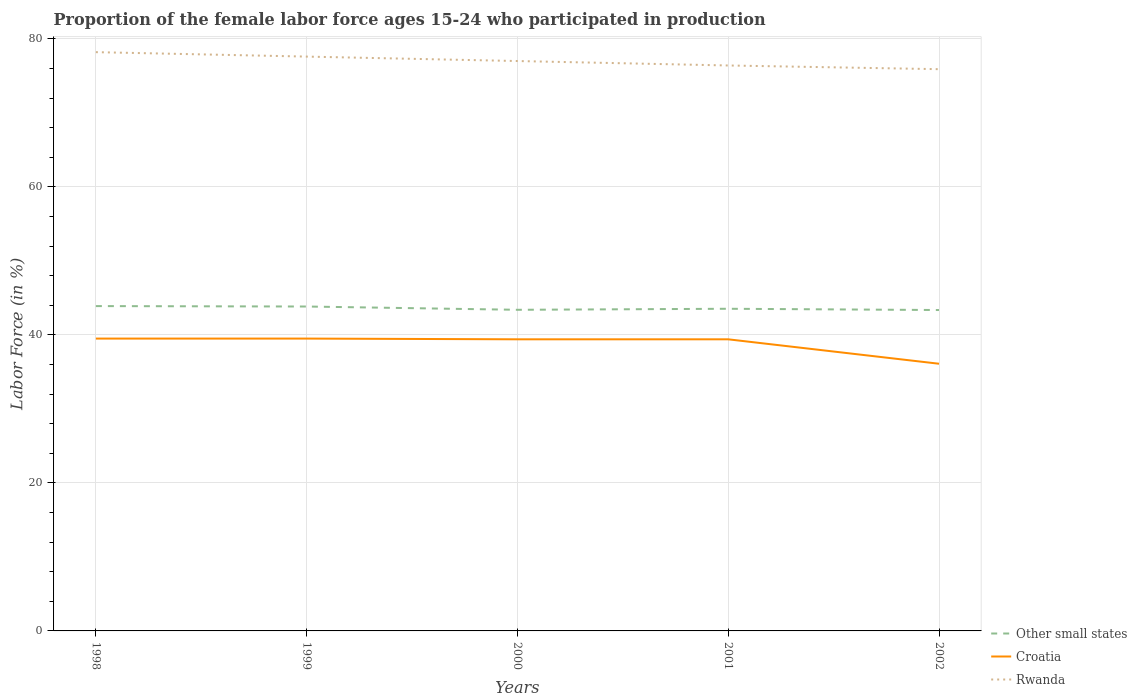Does the line corresponding to Other small states intersect with the line corresponding to Rwanda?
Your answer should be compact. No. Across all years, what is the maximum proportion of the female labor force who participated in production in Other small states?
Provide a succinct answer. 43.36. In which year was the proportion of the female labor force who participated in production in Rwanda maximum?
Offer a very short reply. 2002. What is the total proportion of the female labor force who participated in production in Rwanda in the graph?
Make the answer very short. 0.6. What is the difference between the highest and the second highest proportion of the female labor force who participated in production in Rwanda?
Offer a terse response. 2.3. What is the difference between the highest and the lowest proportion of the female labor force who participated in production in Croatia?
Give a very brief answer. 4. Is the proportion of the female labor force who participated in production in Croatia strictly greater than the proportion of the female labor force who participated in production in Rwanda over the years?
Make the answer very short. Yes. How many lines are there?
Provide a succinct answer. 3. How many years are there in the graph?
Your response must be concise. 5. Are the values on the major ticks of Y-axis written in scientific E-notation?
Give a very brief answer. No. Does the graph contain grids?
Offer a terse response. Yes. Where does the legend appear in the graph?
Your answer should be compact. Bottom right. How many legend labels are there?
Ensure brevity in your answer.  3. What is the title of the graph?
Offer a terse response. Proportion of the female labor force ages 15-24 who participated in production. What is the label or title of the X-axis?
Your answer should be very brief. Years. What is the Labor Force (in %) of Other small states in 1998?
Your response must be concise. 43.89. What is the Labor Force (in %) in Croatia in 1998?
Ensure brevity in your answer.  39.5. What is the Labor Force (in %) in Rwanda in 1998?
Keep it short and to the point. 78.2. What is the Labor Force (in %) in Other small states in 1999?
Keep it short and to the point. 43.83. What is the Labor Force (in %) in Croatia in 1999?
Provide a short and direct response. 39.5. What is the Labor Force (in %) of Rwanda in 1999?
Give a very brief answer. 77.6. What is the Labor Force (in %) in Other small states in 2000?
Your response must be concise. 43.39. What is the Labor Force (in %) of Croatia in 2000?
Offer a very short reply. 39.4. What is the Labor Force (in %) of Rwanda in 2000?
Give a very brief answer. 77. What is the Labor Force (in %) of Other small states in 2001?
Provide a short and direct response. 43.53. What is the Labor Force (in %) in Croatia in 2001?
Offer a terse response. 39.4. What is the Labor Force (in %) in Rwanda in 2001?
Give a very brief answer. 76.4. What is the Labor Force (in %) in Other small states in 2002?
Ensure brevity in your answer.  43.36. What is the Labor Force (in %) in Croatia in 2002?
Your response must be concise. 36.1. What is the Labor Force (in %) of Rwanda in 2002?
Provide a succinct answer. 75.9. Across all years, what is the maximum Labor Force (in %) of Other small states?
Your response must be concise. 43.89. Across all years, what is the maximum Labor Force (in %) of Croatia?
Offer a terse response. 39.5. Across all years, what is the maximum Labor Force (in %) of Rwanda?
Give a very brief answer. 78.2. Across all years, what is the minimum Labor Force (in %) in Other small states?
Ensure brevity in your answer.  43.36. Across all years, what is the minimum Labor Force (in %) of Croatia?
Ensure brevity in your answer.  36.1. Across all years, what is the minimum Labor Force (in %) in Rwanda?
Offer a very short reply. 75.9. What is the total Labor Force (in %) in Other small states in the graph?
Your answer should be compact. 218. What is the total Labor Force (in %) in Croatia in the graph?
Provide a short and direct response. 193.9. What is the total Labor Force (in %) of Rwanda in the graph?
Give a very brief answer. 385.1. What is the difference between the Labor Force (in %) of Other small states in 1998 and that in 1999?
Your answer should be very brief. 0.06. What is the difference between the Labor Force (in %) of Other small states in 1998 and that in 2000?
Provide a succinct answer. 0.5. What is the difference between the Labor Force (in %) of Croatia in 1998 and that in 2000?
Provide a succinct answer. 0.1. What is the difference between the Labor Force (in %) in Rwanda in 1998 and that in 2000?
Offer a terse response. 1.2. What is the difference between the Labor Force (in %) in Other small states in 1998 and that in 2001?
Provide a succinct answer. 0.36. What is the difference between the Labor Force (in %) in Croatia in 1998 and that in 2001?
Offer a very short reply. 0.1. What is the difference between the Labor Force (in %) in Rwanda in 1998 and that in 2001?
Provide a short and direct response. 1.8. What is the difference between the Labor Force (in %) of Other small states in 1998 and that in 2002?
Give a very brief answer. 0.53. What is the difference between the Labor Force (in %) in Croatia in 1998 and that in 2002?
Provide a succinct answer. 3.4. What is the difference between the Labor Force (in %) in Other small states in 1999 and that in 2000?
Keep it short and to the point. 0.44. What is the difference between the Labor Force (in %) in Croatia in 1999 and that in 2000?
Make the answer very short. 0.1. What is the difference between the Labor Force (in %) in Rwanda in 1999 and that in 2000?
Provide a succinct answer. 0.6. What is the difference between the Labor Force (in %) of Other small states in 1999 and that in 2001?
Your response must be concise. 0.3. What is the difference between the Labor Force (in %) of Rwanda in 1999 and that in 2001?
Provide a short and direct response. 1.2. What is the difference between the Labor Force (in %) of Other small states in 1999 and that in 2002?
Offer a very short reply. 0.47. What is the difference between the Labor Force (in %) of Rwanda in 1999 and that in 2002?
Ensure brevity in your answer.  1.7. What is the difference between the Labor Force (in %) of Other small states in 2000 and that in 2001?
Give a very brief answer. -0.14. What is the difference between the Labor Force (in %) of Croatia in 2000 and that in 2001?
Make the answer very short. 0. What is the difference between the Labor Force (in %) of Rwanda in 2000 and that in 2001?
Ensure brevity in your answer.  0.6. What is the difference between the Labor Force (in %) in Other small states in 2000 and that in 2002?
Offer a terse response. 0.03. What is the difference between the Labor Force (in %) in Croatia in 2000 and that in 2002?
Give a very brief answer. 3.3. What is the difference between the Labor Force (in %) in Rwanda in 2000 and that in 2002?
Your answer should be very brief. 1.1. What is the difference between the Labor Force (in %) of Other small states in 2001 and that in 2002?
Your answer should be very brief. 0.17. What is the difference between the Labor Force (in %) in Croatia in 2001 and that in 2002?
Offer a terse response. 3.3. What is the difference between the Labor Force (in %) of Rwanda in 2001 and that in 2002?
Keep it short and to the point. 0.5. What is the difference between the Labor Force (in %) of Other small states in 1998 and the Labor Force (in %) of Croatia in 1999?
Your answer should be very brief. 4.39. What is the difference between the Labor Force (in %) of Other small states in 1998 and the Labor Force (in %) of Rwanda in 1999?
Your answer should be compact. -33.71. What is the difference between the Labor Force (in %) in Croatia in 1998 and the Labor Force (in %) in Rwanda in 1999?
Keep it short and to the point. -38.1. What is the difference between the Labor Force (in %) in Other small states in 1998 and the Labor Force (in %) in Croatia in 2000?
Ensure brevity in your answer.  4.49. What is the difference between the Labor Force (in %) in Other small states in 1998 and the Labor Force (in %) in Rwanda in 2000?
Your answer should be very brief. -33.11. What is the difference between the Labor Force (in %) of Croatia in 1998 and the Labor Force (in %) of Rwanda in 2000?
Make the answer very short. -37.5. What is the difference between the Labor Force (in %) of Other small states in 1998 and the Labor Force (in %) of Croatia in 2001?
Make the answer very short. 4.49. What is the difference between the Labor Force (in %) of Other small states in 1998 and the Labor Force (in %) of Rwanda in 2001?
Ensure brevity in your answer.  -32.51. What is the difference between the Labor Force (in %) in Croatia in 1998 and the Labor Force (in %) in Rwanda in 2001?
Make the answer very short. -36.9. What is the difference between the Labor Force (in %) of Other small states in 1998 and the Labor Force (in %) of Croatia in 2002?
Offer a terse response. 7.79. What is the difference between the Labor Force (in %) in Other small states in 1998 and the Labor Force (in %) in Rwanda in 2002?
Keep it short and to the point. -32.01. What is the difference between the Labor Force (in %) of Croatia in 1998 and the Labor Force (in %) of Rwanda in 2002?
Provide a succinct answer. -36.4. What is the difference between the Labor Force (in %) in Other small states in 1999 and the Labor Force (in %) in Croatia in 2000?
Offer a very short reply. 4.43. What is the difference between the Labor Force (in %) of Other small states in 1999 and the Labor Force (in %) of Rwanda in 2000?
Offer a very short reply. -33.17. What is the difference between the Labor Force (in %) in Croatia in 1999 and the Labor Force (in %) in Rwanda in 2000?
Offer a terse response. -37.5. What is the difference between the Labor Force (in %) in Other small states in 1999 and the Labor Force (in %) in Croatia in 2001?
Ensure brevity in your answer.  4.43. What is the difference between the Labor Force (in %) of Other small states in 1999 and the Labor Force (in %) of Rwanda in 2001?
Ensure brevity in your answer.  -32.57. What is the difference between the Labor Force (in %) in Croatia in 1999 and the Labor Force (in %) in Rwanda in 2001?
Ensure brevity in your answer.  -36.9. What is the difference between the Labor Force (in %) in Other small states in 1999 and the Labor Force (in %) in Croatia in 2002?
Your answer should be compact. 7.73. What is the difference between the Labor Force (in %) of Other small states in 1999 and the Labor Force (in %) of Rwanda in 2002?
Give a very brief answer. -32.07. What is the difference between the Labor Force (in %) in Croatia in 1999 and the Labor Force (in %) in Rwanda in 2002?
Offer a very short reply. -36.4. What is the difference between the Labor Force (in %) of Other small states in 2000 and the Labor Force (in %) of Croatia in 2001?
Offer a very short reply. 3.99. What is the difference between the Labor Force (in %) of Other small states in 2000 and the Labor Force (in %) of Rwanda in 2001?
Offer a very short reply. -33.01. What is the difference between the Labor Force (in %) of Croatia in 2000 and the Labor Force (in %) of Rwanda in 2001?
Offer a very short reply. -37. What is the difference between the Labor Force (in %) in Other small states in 2000 and the Labor Force (in %) in Croatia in 2002?
Give a very brief answer. 7.29. What is the difference between the Labor Force (in %) in Other small states in 2000 and the Labor Force (in %) in Rwanda in 2002?
Your response must be concise. -32.51. What is the difference between the Labor Force (in %) of Croatia in 2000 and the Labor Force (in %) of Rwanda in 2002?
Offer a terse response. -36.5. What is the difference between the Labor Force (in %) in Other small states in 2001 and the Labor Force (in %) in Croatia in 2002?
Provide a short and direct response. 7.43. What is the difference between the Labor Force (in %) of Other small states in 2001 and the Labor Force (in %) of Rwanda in 2002?
Keep it short and to the point. -32.37. What is the difference between the Labor Force (in %) of Croatia in 2001 and the Labor Force (in %) of Rwanda in 2002?
Your answer should be compact. -36.5. What is the average Labor Force (in %) of Other small states per year?
Provide a succinct answer. 43.6. What is the average Labor Force (in %) of Croatia per year?
Provide a succinct answer. 38.78. What is the average Labor Force (in %) in Rwanda per year?
Offer a very short reply. 77.02. In the year 1998, what is the difference between the Labor Force (in %) in Other small states and Labor Force (in %) in Croatia?
Your answer should be compact. 4.39. In the year 1998, what is the difference between the Labor Force (in %) in Other small states and Labor Force (in %) in Rwanda?
Provide a short and direct response. -34.31. In the year 1998, what is the difference between the Labor Force (in %) of Croatia and Labor Force (in %) of Rwanda?
Keep it short and to the point. -38.7. In the year 1999, what is the difference between the Labor Force (in %) of Other small states and Labor Force (in %) of Croatia?
Provide a short and direct response. 4.33. In the year 1999, what is the difference between the Labor Force (in %) in Other small states and Labor Force (in %) in Rwanda?
Your response must be concise. -33.77. In the year 1999, what is the difference between the Labor Force (in %) in Croatia and Labor Force (in %) in Rwanda?
Provide a short and direct response. -38.1. In the year 2000, what is the difference between the Labor Force (in %) of Other small states and Labor Force (in %) of Croatia?
Offer a very short reply. 3.99. In the year 2000, what is the difference between the Labor Force (in %) of Other small states and Labor Force (in %) of Rwanda?
Your answer should be compact. -33.61. In the year 2000, what is the difference between the Labor Force (in %) in Croatia and Labor Force (in %) in Rwanda?
Your answer should be compact. -37.6. In the year 2001, what is the difference between the Labor Force (in %) in Other small states and Labor Force (in %) in Croatia?
Your answer should be compact. 4.13. In the year 2001, what is the difference between the Labor Force (in %) of Other small states and Labor Force (in %) of Rwanda?
Provide a succinct answer. -32.87. In the year 2001, what is the difference between the Labor Force (in %) of Croatia and Labor Force (in %) of Rwanda?
Give a very brief answer. -37. In the year 2002, what is the difference between the Labor Force (in %) in Other small states and Labor Force (in %) in Croatia?
Give a very brief answer. 7.26. In the year 2002, what is the difference between the Labor Force (in %) of Other small states and Labor Force (in %) of Rwanda?
Keep it short and to the point. -32.54. In the year 2002, what is the difference between the Labor Force (in %) of Croatia and Labor Force (in %) of Rwanda?
Your answer should be compact. -39.8. What is the ratio of the Labor Force (in %) in Rwanda in 1998 to that in 1999?
Ensure brevity in your answer.  1.01. What is the ratio of the Labor Force (in %) of Other small states in 1998 to that in 2000?
Ensure brevity in your answer.  1.01. What is the ratio of the Labor Force (in %) in Croatia in 1998 to that in 2000?
Ensure brevity in your answer.  1. What is the ratio of the Labor Force (in %) of Rwanda in 1998 to that in 2000?
Provide a succinct answer. 1.02. What is the ratio of the Labor Force (in %) in Other small states in 1998 to that in 2001?
Provide a succinct answer. 1.01. What is the ratio of the Labor Force (in %) in Croatia in 1998 to that in 2001?
Your answer should be very brief. 1. What is the ratio of the Labor Force (in %) in Rwanda in 1998 to that in 2001?
Your answer should be very brief. 1.02. What is the ratio of the Labor Force (in %) of Other small states in 1998 to that in 2002?
Provide a succinct answer. 1.01. What is the ratio of the Labor Force (in %) of Croatia in 1998 to that in 2002?
Offer a very short reply. 1.09. What is the ratio of the Labor Force (in %) of Rwanda in 1998 to that in 2002?
Your response must be concise. 1.03. What is the ratio of the Labor Force (in %) in Other small states in 1999 to that in 2000?
Keep it short and to the point. 1.01. What is the ratio of the Labor Force (in %) of Croatia in 1999 to that in 2000?
Offer a very short reply. 1. What is the ratio of the Labor Force (in %) of Rwanda in 1999 to that in 2000?
Ensure brevity in your answer.  1.01. What is the ratio of the Labor Force (in %) in Rwanda in 1999 to that in 2001?
Make the answer very short. 1.02. What is the ratio of the Labor Force (in %) of Other small states in 1999 to that in 2002?
Offer a very short reply. 1.01. What is the ratio of the Labor Force (in %) in Croatia in 1999 to that in 2002?
Keep it short and to the point. 1.09. What is the ratio of the Labor Force (in %) of Rwanda in 1999 to that in 2002?
Your response must be concise. 1.02. What is the ratio of the Labor Force (in %) in Other small states in 2000 to that in 2001?
Your response must be concise. 1. What is the ratio of the Labor Force (in %) of Croatia in 2000 to that in 2001?
Your response must be concise. 1. What is the ratio of the Labor Force (in %) of Rwanda in 2000 to that in 2001?
Provide a short and direct response. 1.01. What is the ratio of the Labor Force (in %) of Other small states in 2000 to that in 2002?
Offer a terse response. 1. What is the ratio of the Labor Force (in %) in Croatia in 2000 to that in 2002?
Your answer should be very brief. 1.09. What is the ratio of the Labor Force (in %) of Rwanda in 2000 to that in 2002?
Your response must be concise. 1.01. What is the ratio of the Labor Force (in %) in Other small states in 2001 to that in 2002?
Your answer should be very brief. 1. What is the ratio of the Labor Force (in %) in Croatia in 2001 to that in 2002?
Ensure brevity in your answer.  1.09. What is the ratio of the Labor Force (in %) in Rwanda in 2001 to that in 2002?
Offer a terse response. 1.01. What is the difference between the highest and the second highest Labor Force (in %) of Other small states?
Your answer should be very brief. 0.06. What is the difference between the highest and the lowest Labor Force (in %) in Other small states?
Your response must be concise. 0.53. What is the difference between the highest and the lowest Labor Force (in %) in Rwanda?
Offer a very short reply. 2.3. 